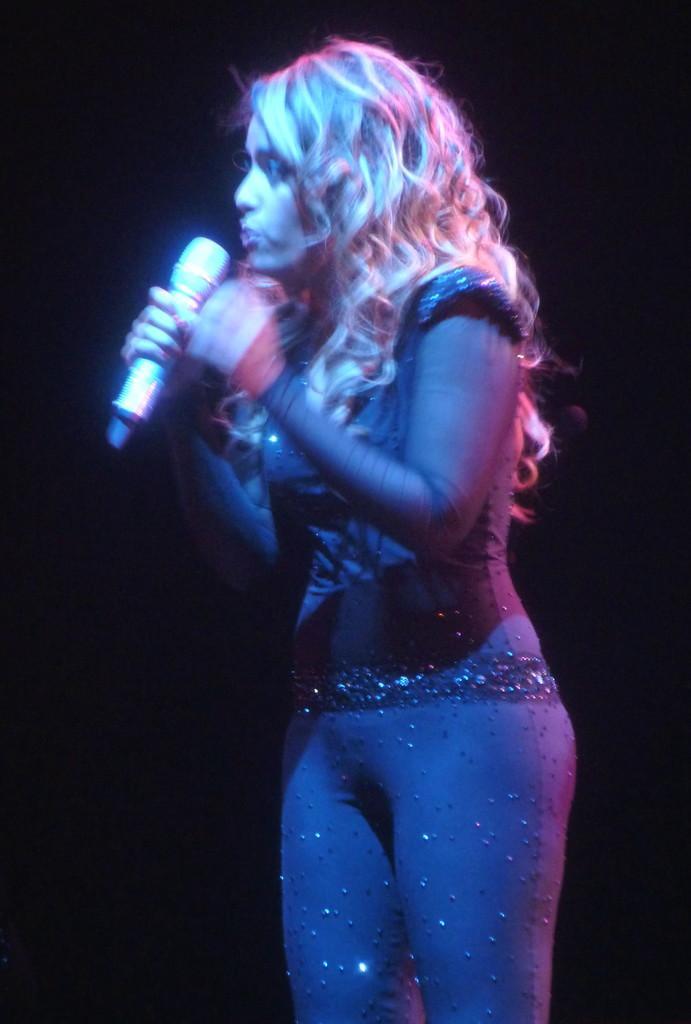How would you summarize this image in a sentence or two? Background of the picture is dark. Here we can see one women stand and holding a music her hand and she is singing. She wore a pretty black colour dress. 